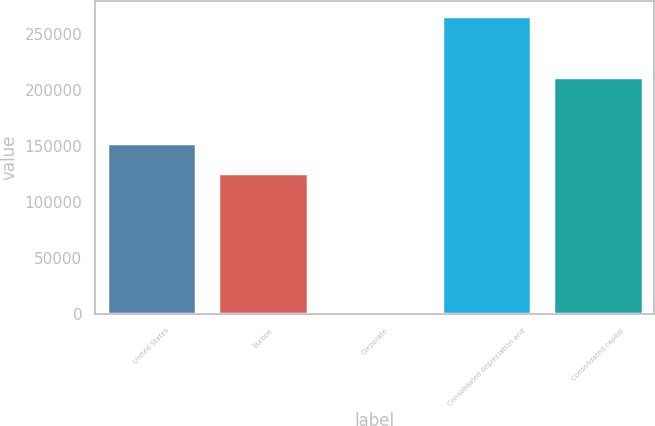Convert chart to OTSL. <chart><loc_0><loc_0><loc_500><loc_500><bar_chart><fcel>United States<fcel>Europe<fcel>Corporate<fcel>Consolidated depreciation and<fcel>Consolidated capital<nl><fcel>152585<fcel>125994<fcel>10<fcel>265921<fcel>211530<nl></chart> 